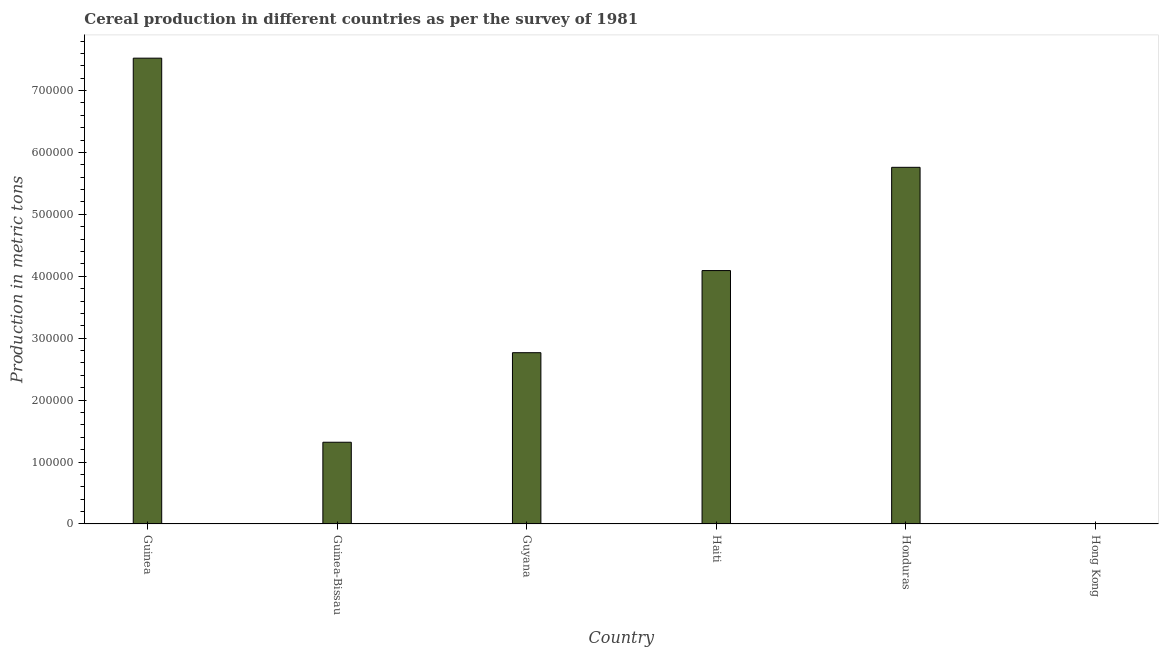Does the graph contain any zero values?
Ensure brevity in your answer.  No. What is the title of the graph?
Your response must be concise. Cereal production in different countries as per the survey of 1981. What is the label or title of the X-axis?
Your answer should be very brief. Country. What is the label or title of the Y-axis?
Your response must be concise. Production in metric tons. What is the cereal production in Guyana?
Offer a terse response. 2.77e+05. Across all countries, what is the maximum cereal production?
Offer a very short reply. 7.52e+05. Across all countries, what is the minimum cereal production?
Ensure brevity in your answer.  30. In which country was the cereal production maximum?
Make the answer very short. Guinea. In which country was the cereal production minimum?
Offer a very short reply. Hong Kong. What is the sum of the cereal production?
Provide a short and direct response. 2.15e+06. What is the difference between the cereal production in Guyana and Hong Kong?
Give a very brief answer. 2.77e+05. What is the average cereal production per country?
Your answer should be compact. 3.58e+05. What is the median cereal production?
Your answer should be very brief. 3.43e+05. What is the ratio of the cereal production in Guyana to that in Haiti?
Your answer should be compact. 0.68. Is the cereal production in Guinea-Bissau less than that in Guyana?
Provide a short and direct response. Yes. Is the difference between the cereal production in Haiti and Hong Kong greater than the difference between any two countries?
Give a very brief answer. No. What is the difference between the highest and the second highest cereal production?
Make the answer very short. 1.76e+05. What is the difference between the highest and the lowest cereal production?
Make the answer very short. 7.52e+05. How many bars are there?
Keep it short and to the point. 6. Are all the bars in the graph horizontal?
Provide a succinct answer. No. What is the difference between two consecutive major ticks on the Y-axis?
Provide a succinct answer. 1.00e+05. What is the Production in metric tons in Guinea?
Offer a very short reply. 7.52e+05. What is the Production in metric tons of Guinea-Bissau?
Your answer should be compact. 1.32e+05. What is the Production in metric tons of Guyana?
Keep it short and to the point. 2.77e+05. What is the Production in metric tons in Haiti?
Your answer should be compact. 4.09e+05. What is the Production in metric tons of Honduras?
Offer a terse response. 5.76e+05. What is the difference between the Production in metric tons in Guinea and Guinea-Bissau?
Provide a short and direct response. 6.20e+05. What is the difference between the Production in metric tons in Guinea and Guyana?
Keep it short and to the point. 4.76e+05. What is the difference between the Production in metric tons in Guinea and Haiti?
Your answer should be very brief. 3.43e+05. What is the difference between the Production in metric tons in Guinea and Honduras?
Make the answer very short. 1.76e+05. What is the difference between the Production in metric tons in Guinea and Hong Kong?
Ensure brevity in your answer.  7.52e+05. What is the difference between the Production in metric tons in Guinea-Bissau and Guyana?
Make the answer very short. -1.45e+05. What is the difference between the Production in metric tons in Guinea-Bissau and Haiti?
Offer a terse response. -2.77e+05. What is the difference between the Production in metric tons in Guinea-Bissau and Honduras?
Your answer should be very brief. -4.44e+05. What is the difference between the Production in metric tons in Guinea-Bissau and Hong Kong?
Your answer should be compact. 1.32e+05. What is the difference between the Production in metric tons in Guyana and Haiti?
Your answer should be compact. -1.33e+05. What is the difference between the Production in metric tons in Guyana and Honduras?
Your answer should be very brief. -2.99e+05. What is the difference between the Production in metric tons in Guyana and Hong Kong?
Offer a very short reply. 2.77e+05. What is the difference between the Production in metric tons in Haiti and Honduras?
Give a very brief answer. -1.67e+05. What is the difference between the Production in metric tons in Haiti and Hong Kong?
Provide a short and direct response. 4.09e+05. What is the difference between the Production in metric tons in Honduras and Hong Kong?
Offer a terse response. 5.76e+05. What is the ratio of the Production in metric tons in Guinea to that in Guinea-Bissau?
Provide a short and direct response. 5.7. What is the ratio of the Production in metric tons in Guinea to that in Guyana?
Make the answer very short. 2.72. What is the ratio of the Production in metric tons in Guinea to that in Haiti?
Provide a succinct answer. 1.84. What is the ratio of the Production in metric tons in Guinea to that in Honduras?
Ensure brevity in your answer.  1.31. What is the ratio of the Production in metric tons in Guinea to that in Hong Kong?
Provide a short and direct response. 2.51e+04. What is the ratio of the Production in metric tons in Guinea-Bissau to that in Guyana?
Your response must be concise. 0.48. What is the ratio of the Production in metric tons in Guinea-Bissau to that in Haiti?
Make the answer very short. 0.32. What is the ratio of the Production in metric tons in Guinea-Bissau to that in Honduras?
Keep it short and to the point. 0.23. What is the ratio of the Production in metric tons in Guinea-Bissau to that in Hong Kong?
Offer a very short reply. 4400. What is the ratio of the Production in metric tons in Guyana to that in Haiti?
Give a very brief answer. 0.68. What is the ratio of the Production in metric tons in Guyana to that in Honduras?
Provide a succinct answer. 0.48. What is the ratio of the Production in metric tons in Guyana to that in Hong Kong?
Keep it short and to the point. 9221.2. What is the ratio of the Production in metric tons in Haiti to that in Honduras?
Make the answer very short. 0.71. What is the ratio of the Production in metric tons in Haiti to that in Hong Kong?
Provide a succinct answer. 1.36e+04. What is the ratio of the Production in metric tons in Honduras to that in Hong Kong?
Give a very brief answer. 1.92e+04. 